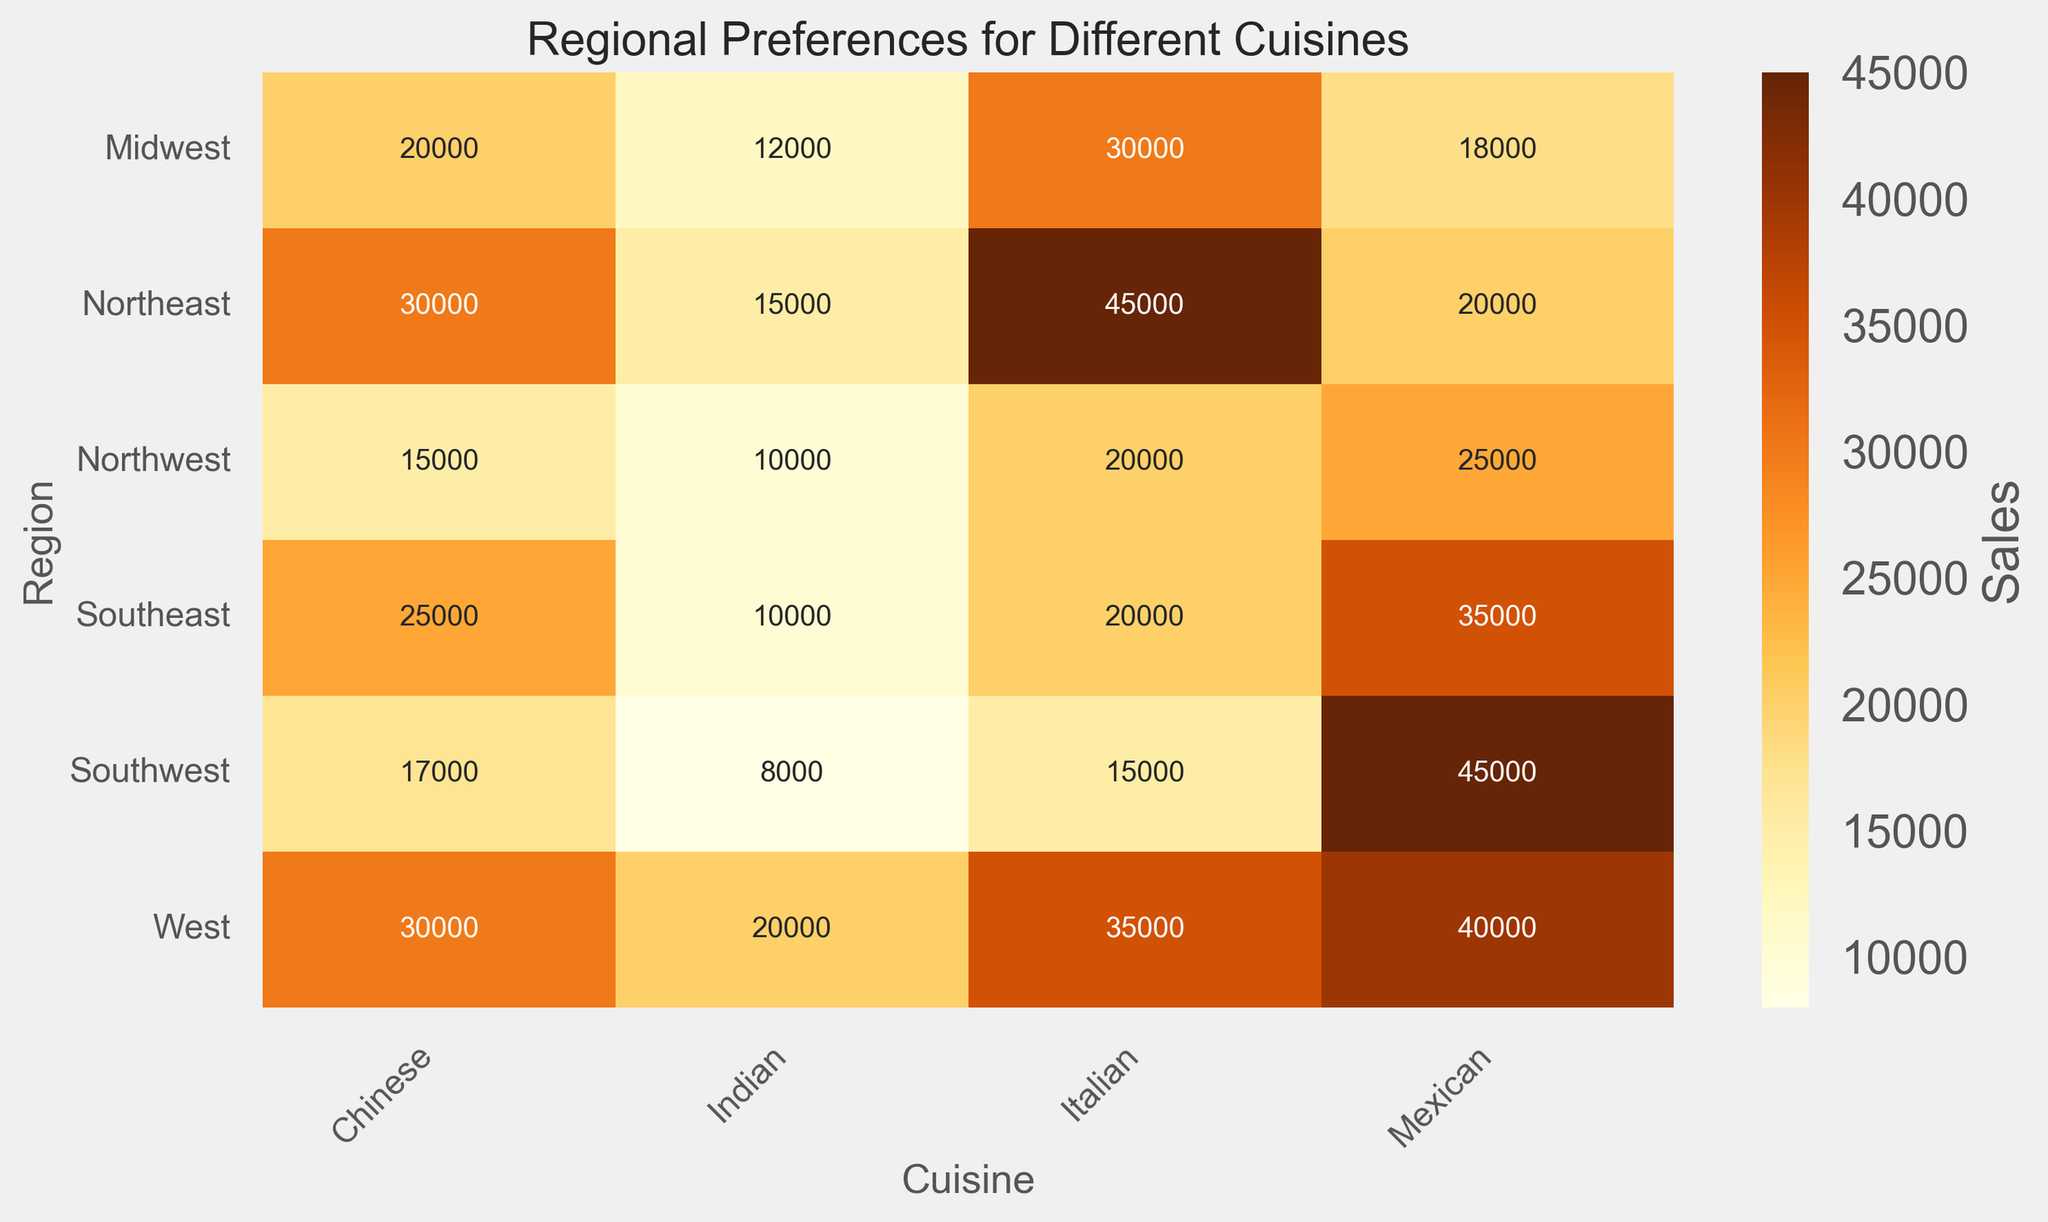What region has the highest sales for Mexican cuisine? To find the region with the highest sales for Mexican cuisine, locate the row with the highest value in the "Mexican" column on the heatmap. In this case, it corresponds to the Southwest region, where the sales are 45,000.
Answer: Southwest What is the difference in sales between Italian cuisine in the Northeast and the Southwest regions? To determine this, subtract the sales figure for Italian cuisine in the Southwest (15,000) from the sales figure for Italian cuisine in the Northeast (45,000). This gives a difference of 45,000 - 15,000.
Answer: 30,000 Which region has the most evenly distributed sales across all cuisines? Look across each row on the heatmap to find the region where the sales figures for each cuisine are the most similar to each other. From the heatmap, the West region has relatively similar sales figures for each cuisine.
Answer: West In which region does Indian cuisine have the lowest sales? To identify the region with the lowest sales for Indian cuisine, find the minimum value in the "Indian" column on the heatmap. The region with the lowest sales is the Southwest, with sales of 8,000.
Answer: Southwest What is the total sales for Chinese cuisine in the Northeast and Southeast regions combined? Add the sales figures for Chinese cuisine in the Northeast (30,000) and Southeast (25,000) to get the total. The calculation is 30,000 + 25,000.
Answer: 55,000 Which cuisine has the highest average sales across all regions? Calculate the average sales for each cuisine by summing the sales for each cuisine across all regions and then dividing by the number of regions (6). For instance, for Italian cuisine: (45000 + 20000 + 30000 + 15000 + 35000 + 20000) / 6 = 27,500. Perform similar calculations for each cuisine and identify the highest average value. Mexican cuisine has the highest average.
Answer: Mexican Is the sales distribution more varied for Indian or Italian cuisine across regions? To assess this, look at the spread of sales values for Indian and Italian cuisines across regions. A wider range of values indicates more variability. Indian sales range from 8,000 to 20,000, and Italian sales range from 15,000 to 45,000. Italian cuisine shows more variability.
Answer: Italian How do the sales for Chinese cuisine in the Midwest compare to those in the West? Compare the sales figures for Chinese cuisine between the two regions. Chinese cuisine in the Midwest has sales of 20,000, whereas in the West, it’s 30,000. Therefore, the sales in the West are higher.
Answer: West What is the combined sales figure for all cuisines in the Northwest region? Sum the sales figures for all cuisines in the Northwest region: Italian (20,000), Chinese (15,000), Mexican (25,000), and Indian (10,000). The total is 20,000 + 15,000 + 25,000 + 10,000.
Answer: 70,000 